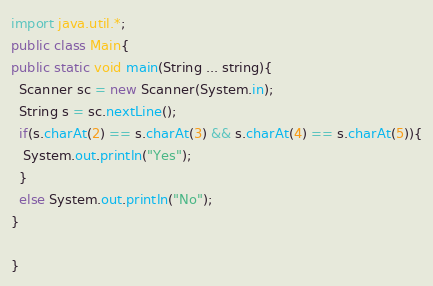Convert code to text. <code><loc_0><loc_0><loc_500><loc_500><_Java_>import java.util.*; 
public class Main{
public static void main(String ... string){
  Scanner sc = new Scanner(System.in); 
  String s = sc.nextLine(); 
  if(s.charAt(2) == s.charAt(3) && s.charAt(4) == s.charAt(5)){
   System.out.println("Yes"); 
  }
  else System.out.println("No"); 
}

}</code> 